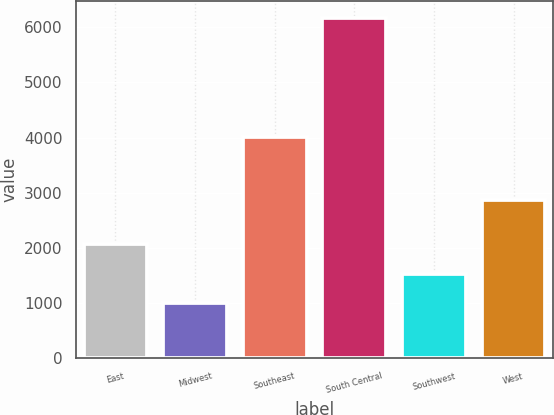<chart> <loc_0><loc_0><loc_500><loc_500><bar_chart><fcel>East<fcel>Midwest<fcel>Southeast<fcel>South Central<fcel>Southwest<fcel>West<nl><fcel>2066<fcel>1005<fcel>4019<fcel>6169<fcel>1521.4<fcel>2878<nl></chart> 